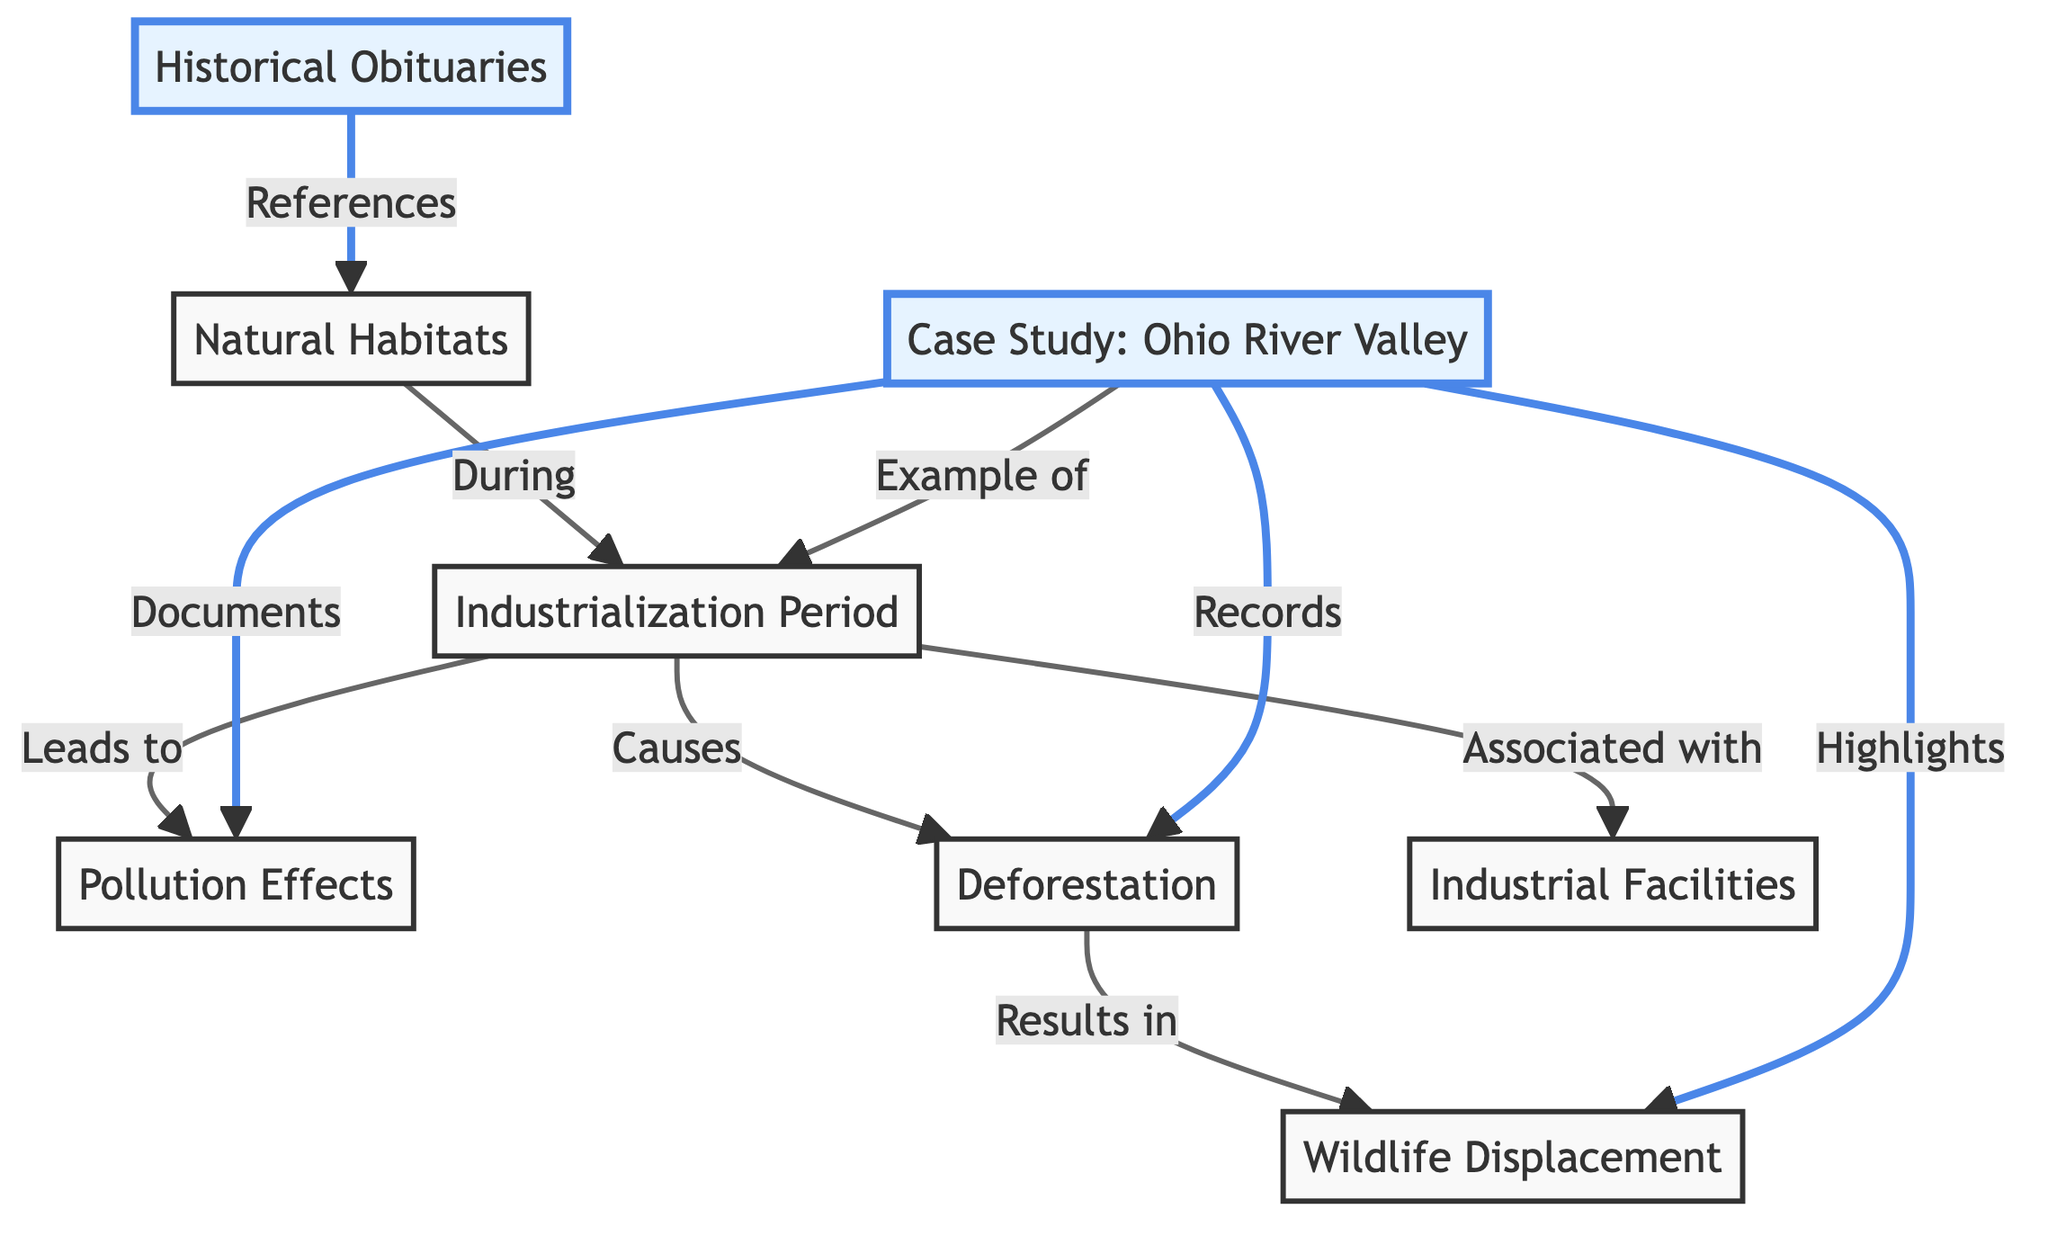What is highlighted in the diagram? The highlighted nodes in the diagram are "Historical Obituaries" and "Case Study: Ohio River Valley."
Answer: Historical Obituaries, Case Study: Ohio River Valley What is the main environmental effect of industrialization mentioned? The main environmental effect indicated in the diagram is "Pollution Effects," which is directly linked to the "Industrialization Period."
Answer: Pollution Effects How many nodes are associated with "Natural Habitats"? The diagram shows the "Natural Habitats" node connected to four other nodes: "Historical Obituaries," "Industrialization Period," "Deforestation," and "Wildlife Displacement." This totals four associated nodes.
Answer: 4 Which node leads to "Wildlife Displacement"? "Deforestation" is the node that leads to "Wildlife Displacement." The diagram indicates that deforestation results in wildlife being displaced.
Answer: Deforestation What period does the "Case Study: Ohio River Valley" represent? The "Case Study: Ohio River Valley" represents the "Industrialization Period," which is documented within the case study of that region.
Answer: Industrialization Period What types of records are highlighted in the "Case Study: Ohio River Valley"? The "Case Study: Ohio River Valley" highlights the effects of pollution, records of deforestation, and observations of wildlife displacement, illustrating the consequences of industrialization.
Answer: Pollution, Deforestation, Wildlife Displacement What is the relationship between "Industrial Facilities" and "Industrialization Period"? "Industrial Facilities" are associated with the "Industrialization Period," indicating their presence as a result of industrial growth during that time.
Answer: Associated with How do pollution effects relate to the industrialization process? The diagram shows that the "Industrialization Period" leads to "Pollution Effects," suggesting that pollution is a direct consequence of industrial activities during that period.
Answer: Leads to Which case study is provided as an example for the industrialization impact? The "Case Study: Ohio River Valley" is provided as an example illustrating the impact of industrialization on natural habitats.
Answer: Ohio River Valley 